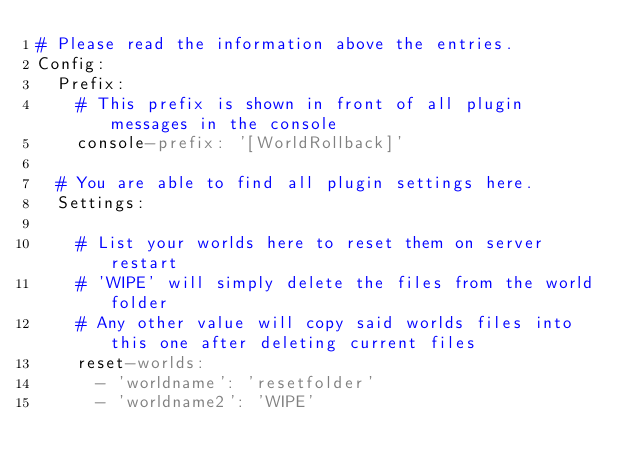<code> <loc_0><loc_0><loc_500><loc_500><_YAML_># Please read the information above the entries.
Config:
  Prefix:
    # This prefix is shown in front of all plugin messages in the console
    console-prefix: '[WorldRollback]'

  # You are able to find all plugin settings here.
  Settings:

    # List your worlds here to reset them on server restart
    # 'WIPE' will simply delete the files from the world folder
    # Any other value will copy said worlds files into this one after deleting current files
    reset-worlds:
      - 'worldname': 'resetfolder'
      - 'worldname2': 'WIPE'</code> 